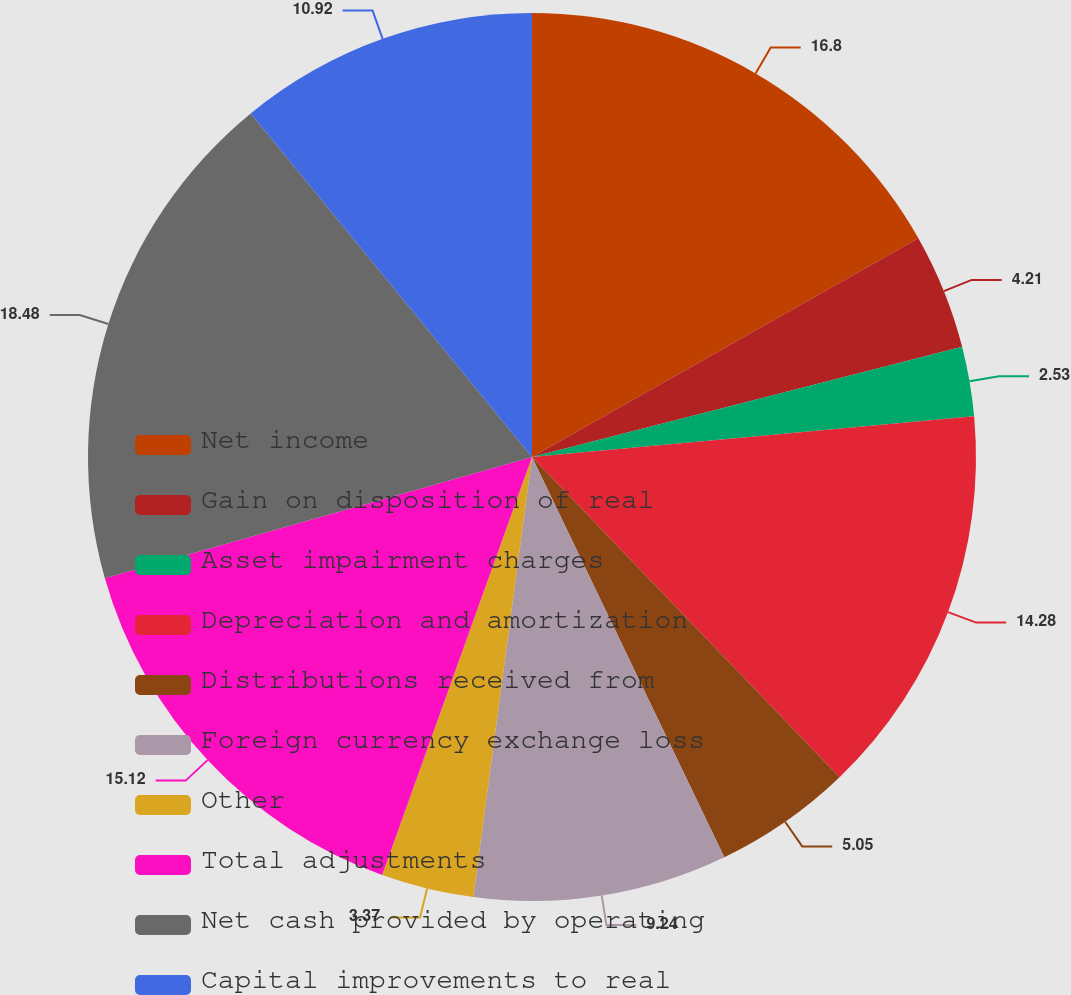<chart> <loc_0><loc_0><loc_500><loc_500><pie_chart><fcel>Net income<fcel>Gain on disposition of real<fcel>Asset impairment charges<fcel>Depreciation and amortization<fcel>Distributions received from<fcel>Foreign currency exchange loss<fcel>Other<fcel>Total adjustments<fcel>Net cash provided by operating<fcel>Capital improvements to real<nl><fcel>16.8%<fcel>4.21%<fcel>2.53%<fcel>14.28%<fcel>5.05%<fcel>9.24%<fcel>3.37%<fcel>15.12%<fcel>18.48%<fcel>10.92%<nl></chart> 